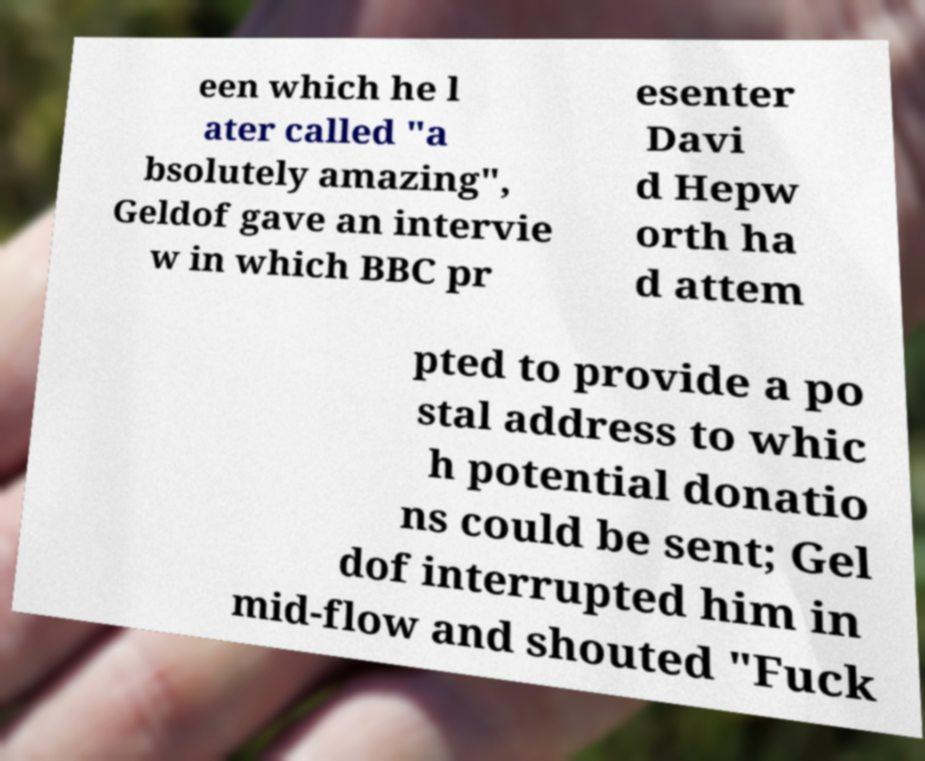What messages or text are displayed in this image? I need them in a readable, typed format. een which he l ater called "a bsolutely amazing", Geldof gave an intervie w in which BBC pr esenter Davi d Hepw orth ha d attem pted to provide a po stal address to whic h potential donatio ns could be sent; Gel dof interrupted him in mid-flow and shouted "Fuck 